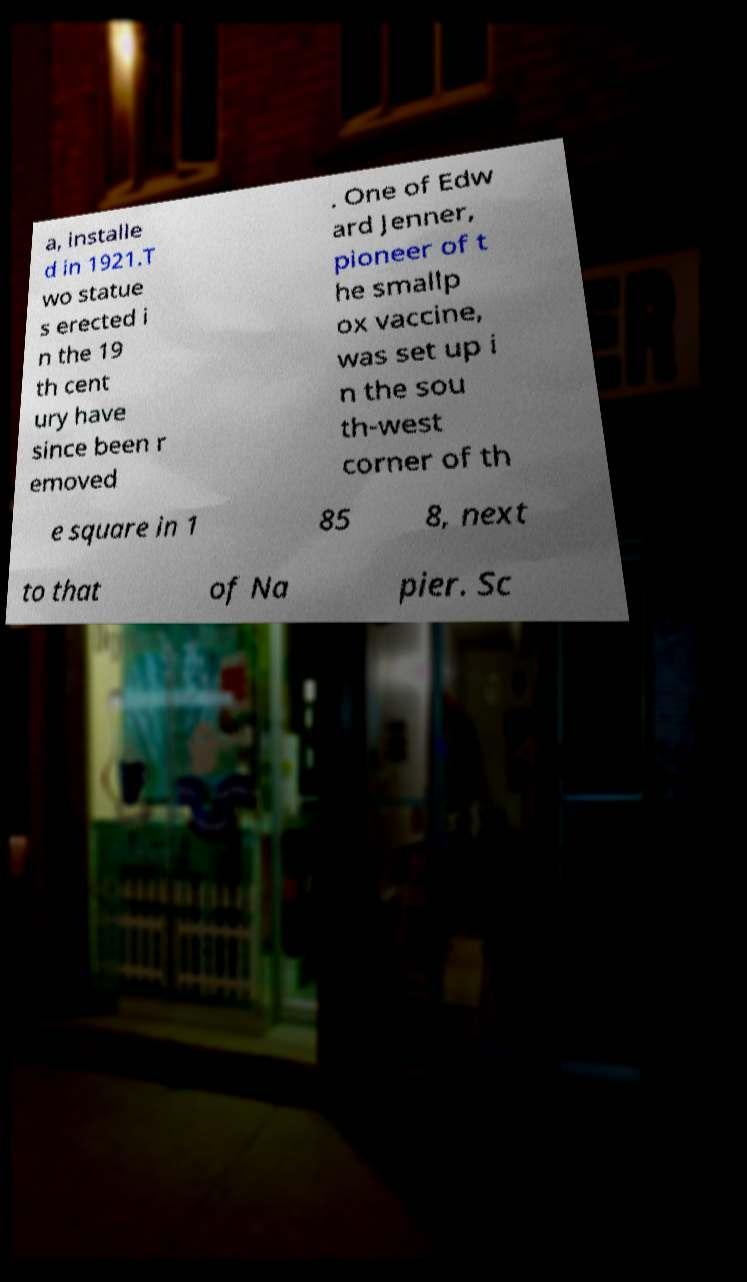Could you assist in decoding the text presented in this image and type it out clearly? a, installe d in 1921.T wo statue s erected i n the 19 th cent ury have since been r emoved . One of Edw ard Jenner, pioneer of t he smallp ox vaccine, was set up i n the sou th-west corner of th e square in 1 85 8, next to that of Na pier. Sc 